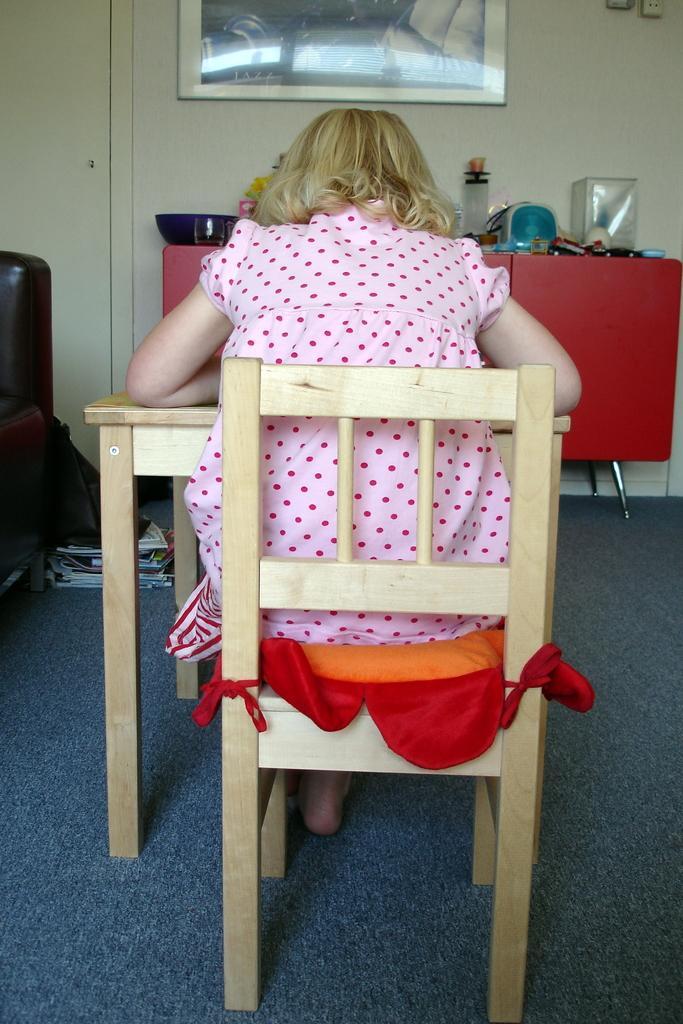Describe this image in one or two sentences. Here a girl is sitting on the chair and resting her hands in the table in the middle of an image there is a wall and a photograph on the wall. 